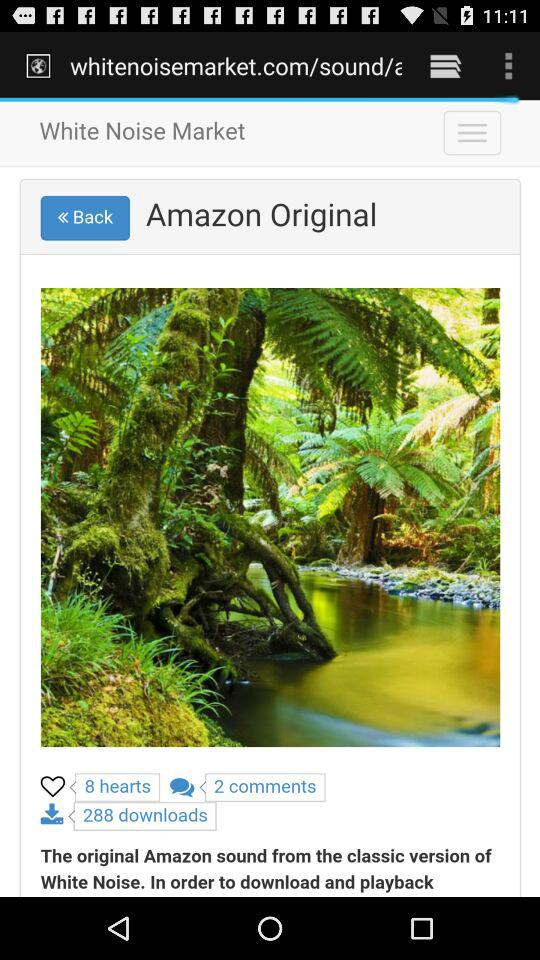What is the count of hearts? The count of hearts is 8. 